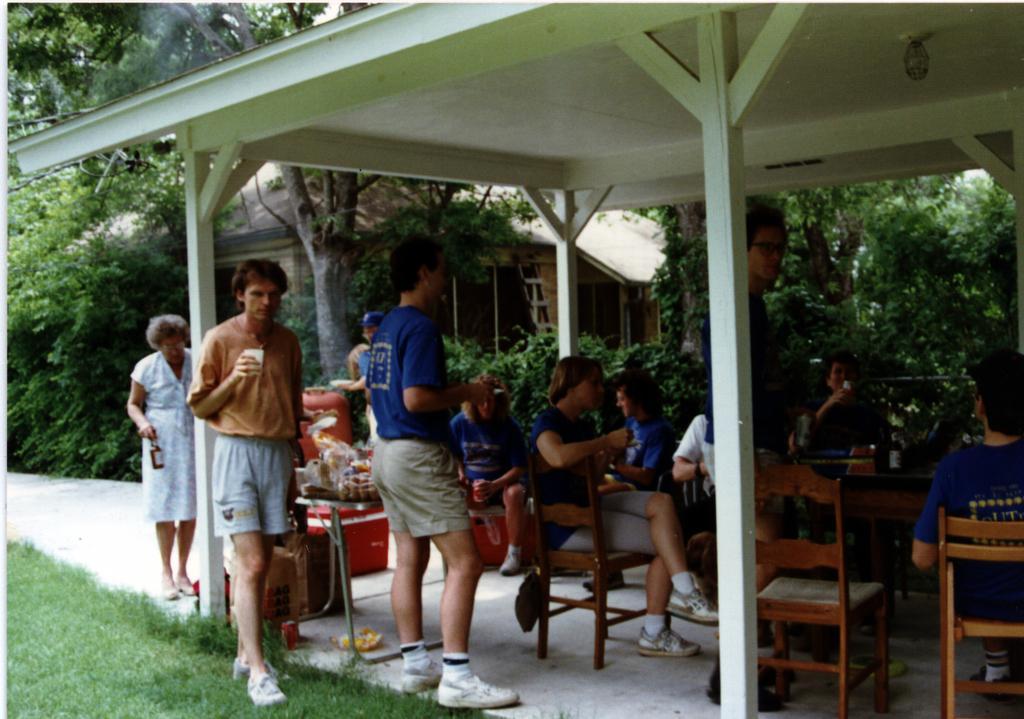Describe this image in one or two sentences. There is a group of people. Some persons are standing and some persons are sitting. We can see in the background there is a beautiful nature like trees,pillars and ladder. On the left side we have a person. He's walking like slowly. He's holding a glass. 